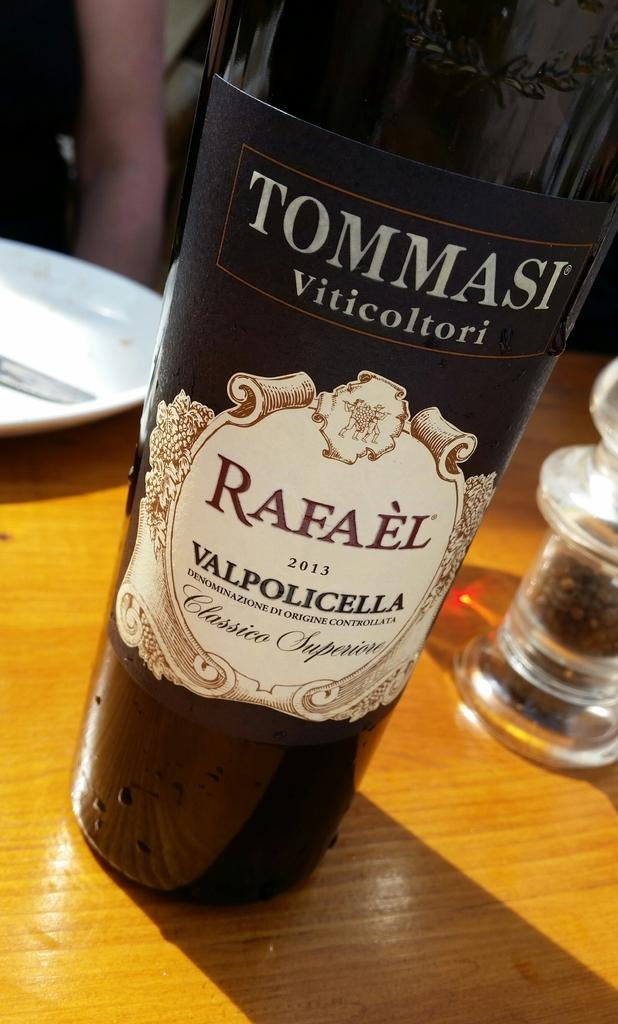<image>
Write a terse but informative summary of the picture. A bottle of Ommasi Viticoltori Rafael from 2013. 